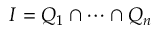<formula> <loc_0><loc_0><loc_500><loc_500>I = Q _ { 1 } \cap \cdots \cap Q _ { n }</formula> 